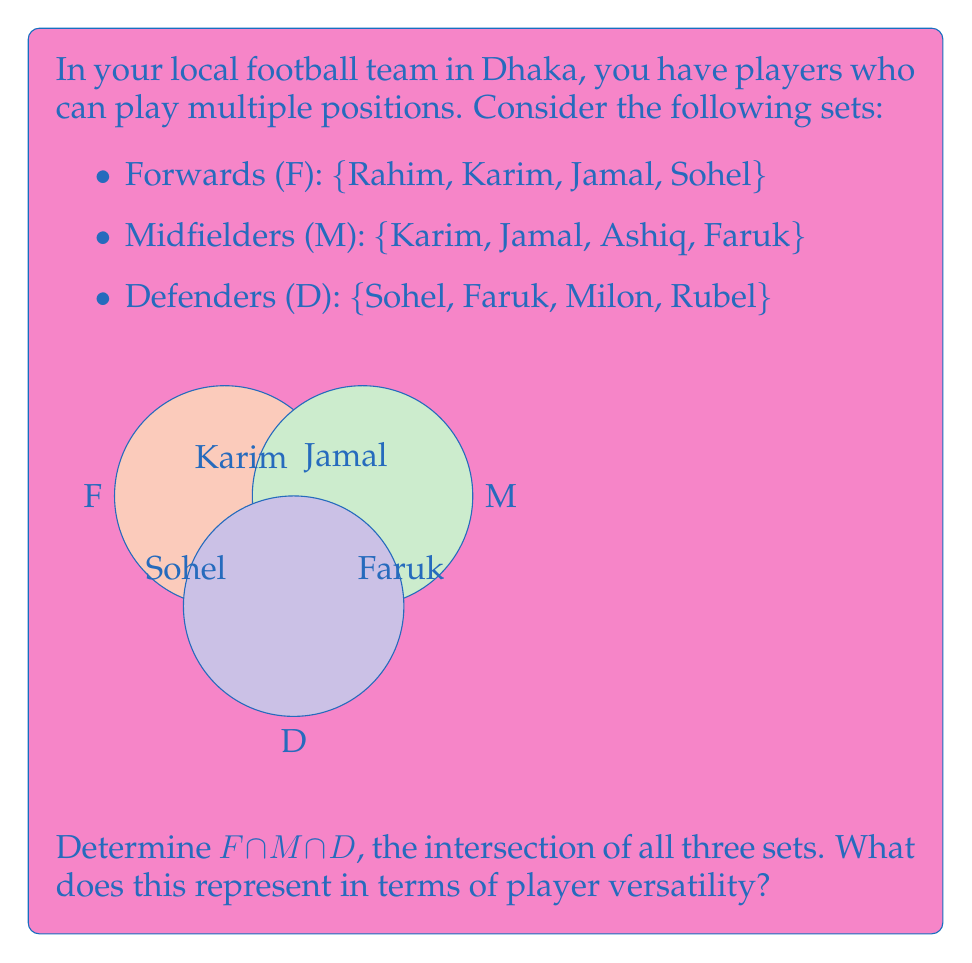Can you answer this question? To find the intersection of all three sets, we need to identify players who are present in all three positions: Forwards (F), Midfielders (M), and Defenders (D).

Step 1: Identify players in F ∩ M
$F \cap M = \{Karim, Jamal\}$

Step 2: Identify players in M ∩ D
$M \cap D = \{Faruk\}$

Step 3: Identify players in F ∩ D
$F \cap D = \{Sohel\}$

Step 4: Find the intersection of all three sets
$F \cap M \cap D = (F \cap M) \cap D = \{Karim, Jamal\} \cap \{Sohel, Faruk, Milon, Rubel\} = \emptyset$

The intersection of all three sets is an empty set, which means there is no player who can play in all three positions (forward, midfielder, and defender).

In terms of player versatility, this result indicates that while some players can play in two different positions, none of the players in the team are versatile enough to play in all three main outfield positions.
Answer: $F \cap M \cap D = \emptyset$ 